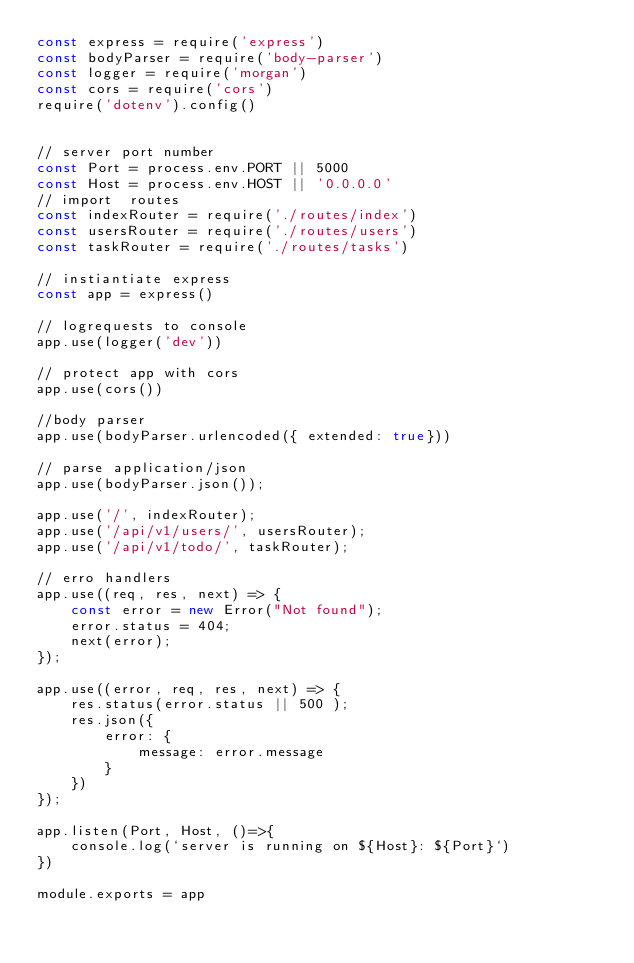<code> <loc_0><loc_0><loc_500><loc_500><_JavaScript_>const express = require('express')
const bodyParser = require('body-parser')
const logger = require('morgan')
const cors = require('cors')
require('dotenv').config()


// server port number
const Port = process.env.PORT || 5000
const Host = process.env.HOST || '0.0.0.0'
// import  routes
const indexRouter = require('./routes/index')
const usersRouter = require('./routes/users')
const taskRouter = require('./routes/tasks')

// instiantiate express
const app = express()

// logrequests to console
app.use(logger('dev'))

// protect app with cors
app.use(cors())

//body parser
app.use(bodyParser.urlencoded({ extended: true}))

// parse application/json
app.use(bodyParser.json());

app.use('/', indexRouter);
app.use('/api/v1/users/', usersRouter);
app.use('/api/v1/todo/', taskRouter);

// erro handlers
app.use((req, res, next) => {
    const error = new Error("Not found");
    error.status = 404;
    next(error);
});

app.use((error, req, res, next) => {
    res.status(error.status || 500 );
    res.json({
        error: {
            message: error.message
        }
    })
});

app.listen(Port, Host, ()=>{
    console.log(`server is running on ${Host}: ${Port}`)
})

module.exports = app
</code> 